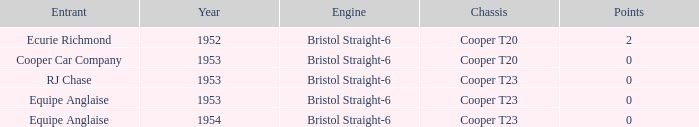Which of the biggest points numbers had a year more recent than 1953? 0.0. 